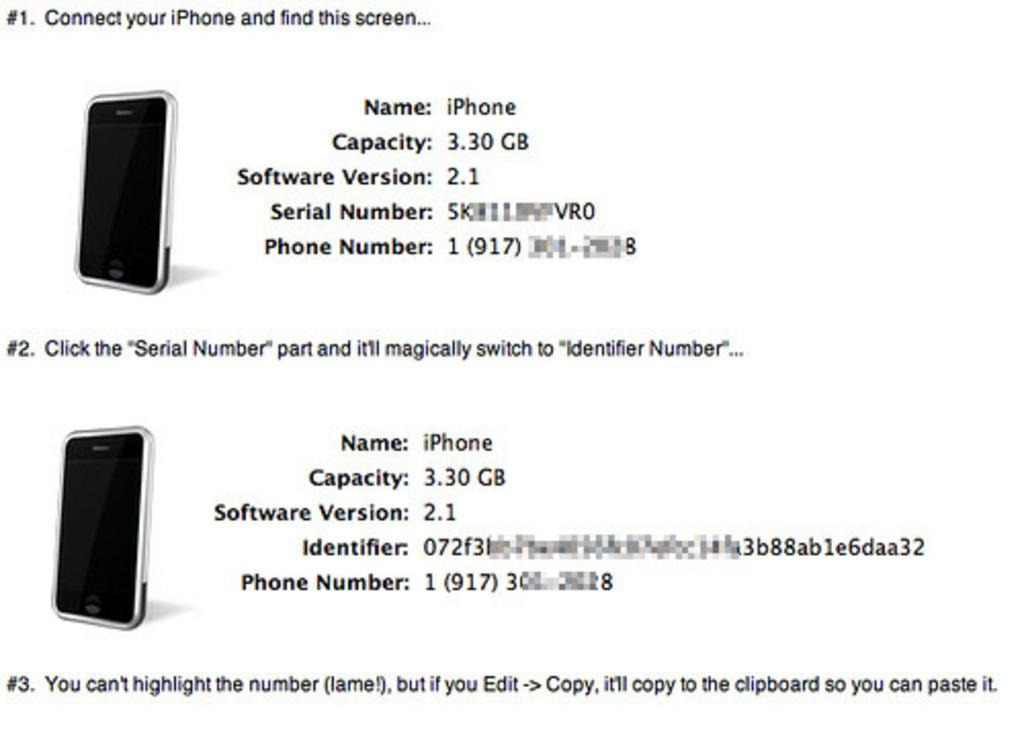<image>
Provide a brief description of the given image. A screen displaying iphones with capacities of 3.30 gigabytes 